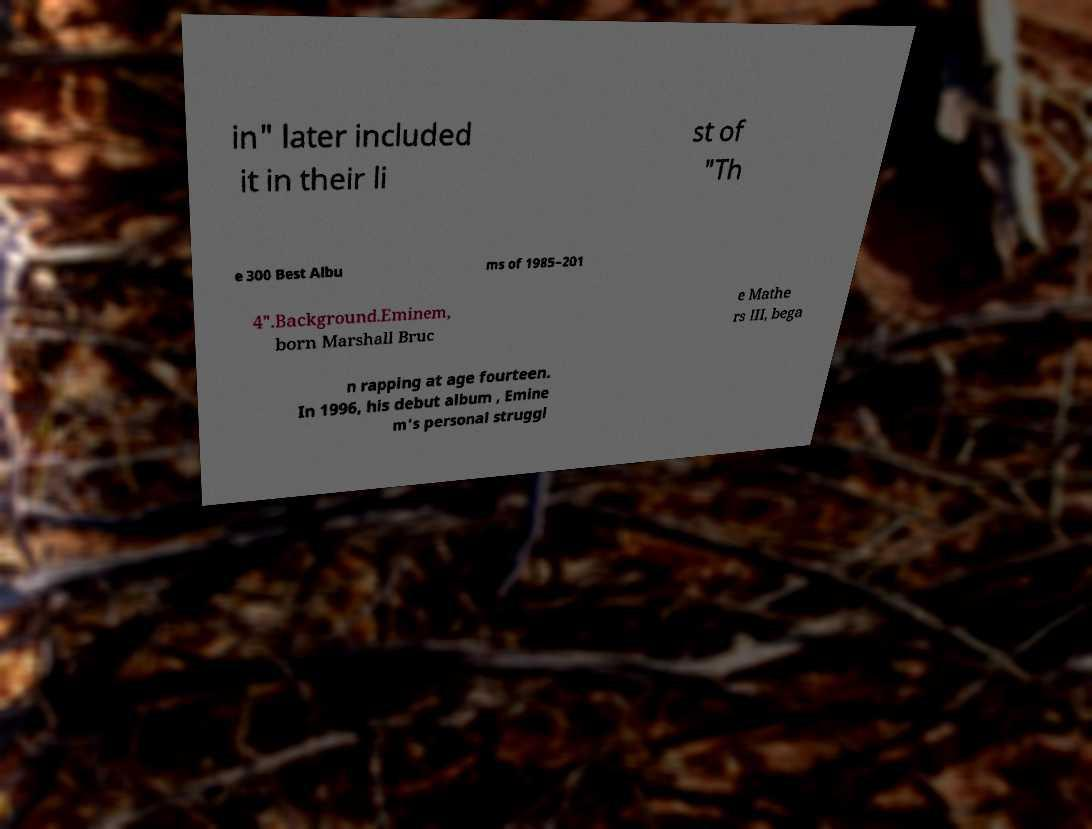Please read and relay the text visible in this image. What does it say? in" later included it in their li st of "Th e 300 Best Albu ms of 1985–201 4".Background.Eminem, born Marshall Bruc e Mathe rs III, bega n rapping at age fourteen. In 1996, his debut album , Emine m's personal struggl 